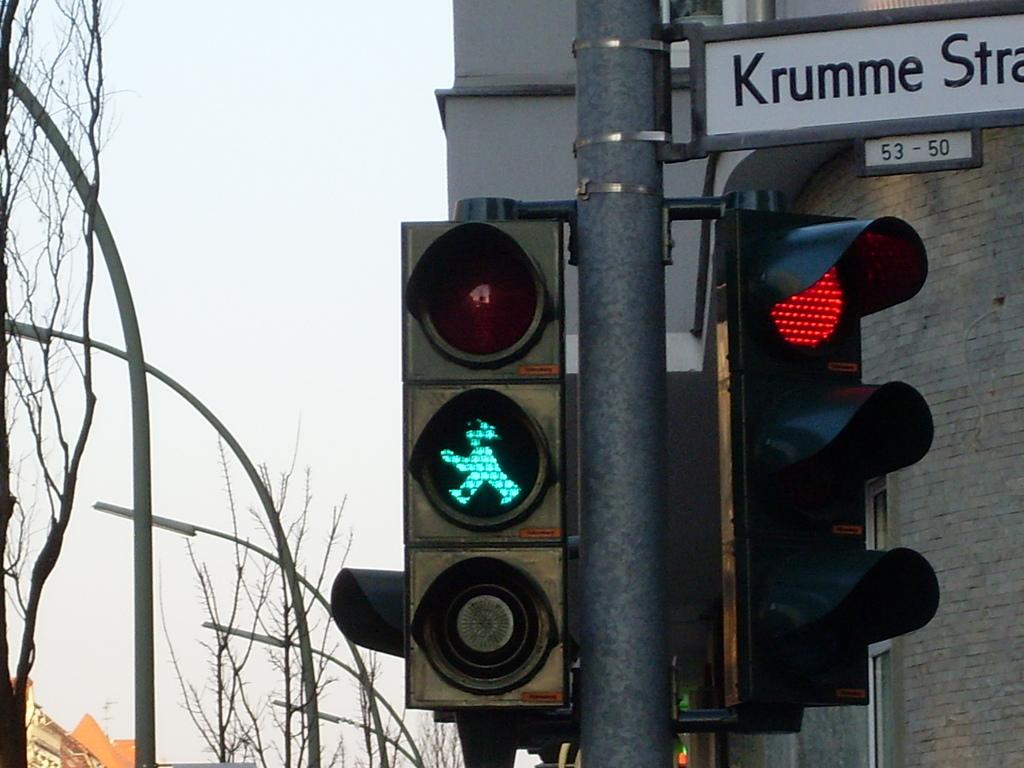What street is the traffic light for?
Ensure brevity in your answer.  Krumme. What is below the street sign?
Keep it short and to the point. 53-50. 